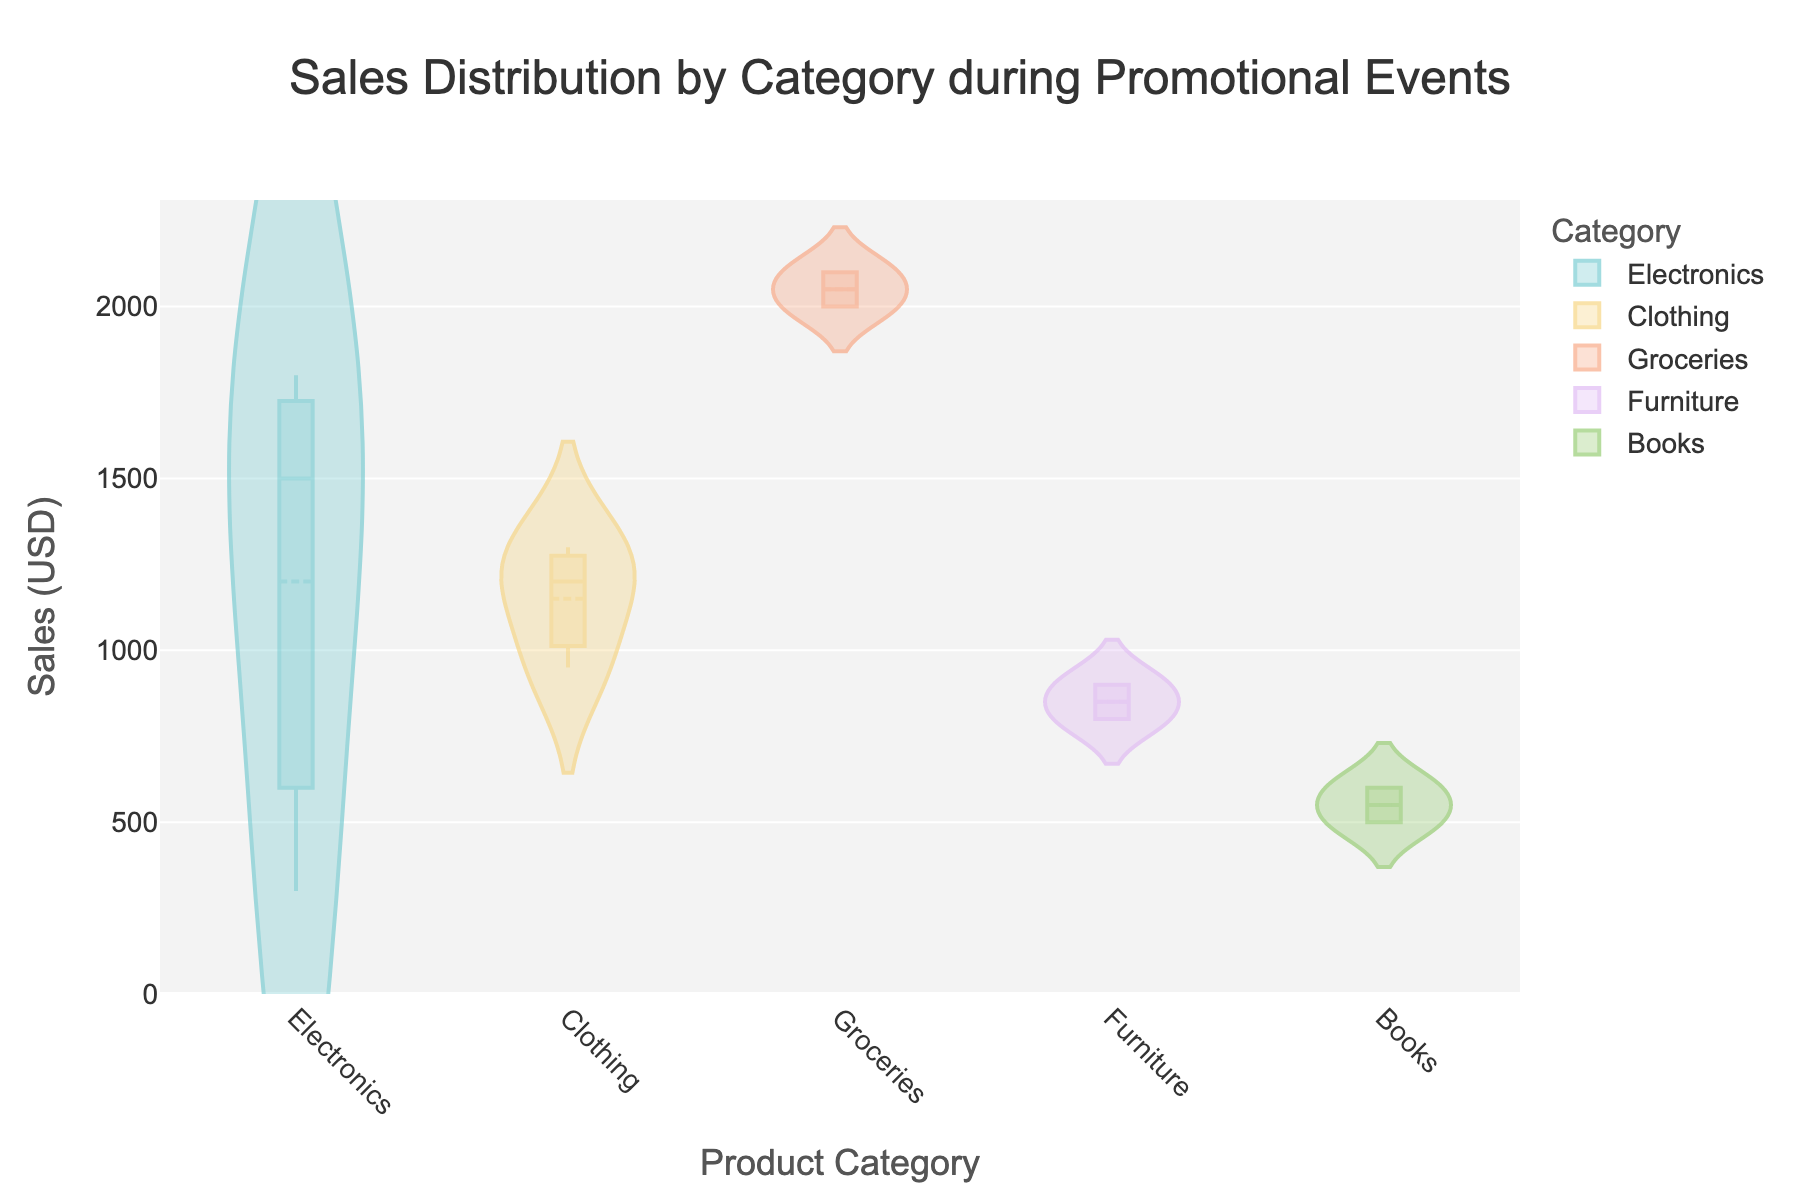What is the title of the figure? The title of the figure is displayed at the top center. It reads "Sales Distribution by Category during Promotional Events".
Answer: Sales Distribution by Category during Promotional Events Which category appears to have the highest maximum sales during the event? By examining the y-axis and the spread of sales values, the "Groceries" category shows the highest maximum sales, reaching up to 2100.
Answer: Groceries How many categories are represented in the figure? Each unique color and label on the x-axis represents a category. There are five categories displayed: Electronics, Clothing, Groceries, Furniture, and Books.
Answer: 5 What is the median sales value for the Electronics category? The median value is depicted by the central horizontal line inside the box for each category. For Electronics, the median value is around 1500.
Answer: 1500 Which categories have overlapping sales ranges? Overlapping sales ranges can be observed by comparing the spread (violin plots) of different categories. "Electronics" and "Clothing" have overlapping ranges between 950 to 1800.
Answer: Electronics and Clothing What is the lowest sales value recorded in the Furniture category? The lowest point in the Furniture violin plot indicates the minimum value. The lowest sales value for Furniture is 800.
Answer: 800 Is the mean line for the Electronics category above or below its median line? The mean line is visible within the violin plot and is compared to the median line. For Electronics, the mean line is slightly above the median line.
Answer: Above Which category has the widest range of sales during the events? The range can be assessed by the overall spread of the violin plot for each category. "Groceries" has the widest range, from around 2000 to 2100.
Answer: Groceries What is the interquartile range (IQR) in the Clothing category? The IQR is the range covered by the box around the median line. For Clothing, the IQR extends from about 950 to 1300. Thus, IQR = 1300 - 950 = 350.
Answer: 350 Which categories have their median sales value above 1000? The median sales value is indicated by the horizontal line within each box. "Electronics," "Clothing," and "Groceries" all have median sales values above 1000.
Answer: Electronics, Clothing, and Groceries 